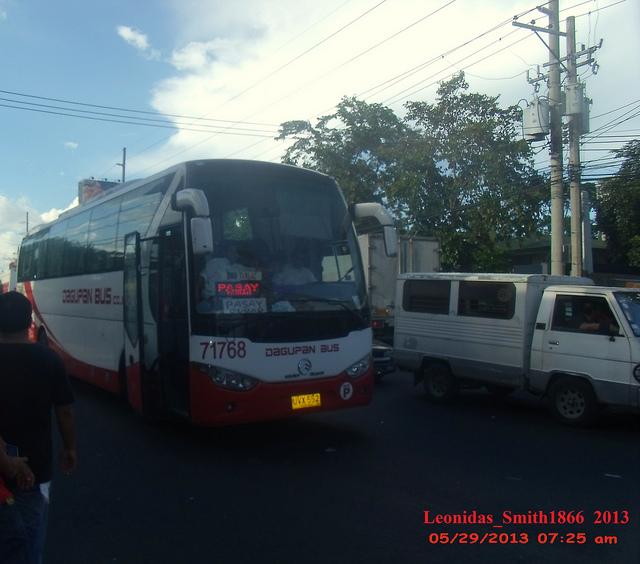What color is the van?
Write a very short answer. White. What number is this bus?
Short answer required. 71768. Where is the license plate on the bus?
Quick response, please. Bottom. What time was this picture taken?
Give a very brief answer. 7:25 am. 